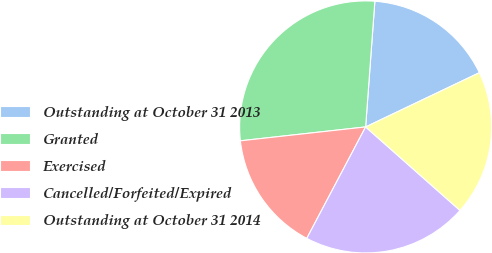<chart> <loc_0><loc_0><loc_500><loc_500><pie_chart><fcel>Outstanding at October 31 2013<fcel>Granted<fcel>Exercised<fcel>Cancelled/Forfeited/Expired<fcel>Outstanding at October 31 2014<nl><fcel>16.75%<fcel>27.92%<fcel>15.51%<fcel>21.2%<fcel>18.61%<nl></chart> 